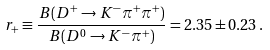Convert formula to latex. <formula><loc_0><loc_0><loc_500><loc_500>r _ { + } \equiv \frac { B ( D ^ { + } \rightarrow K ^ { - } \pi ^ { + } \pi ^ { + } ) } { B ( D ^ { 0 } \rightarrow K ^ { - } \pi ^ { + } ) } = 2 . 3 5 \pm 0 . 2 3 \, .</formula> 